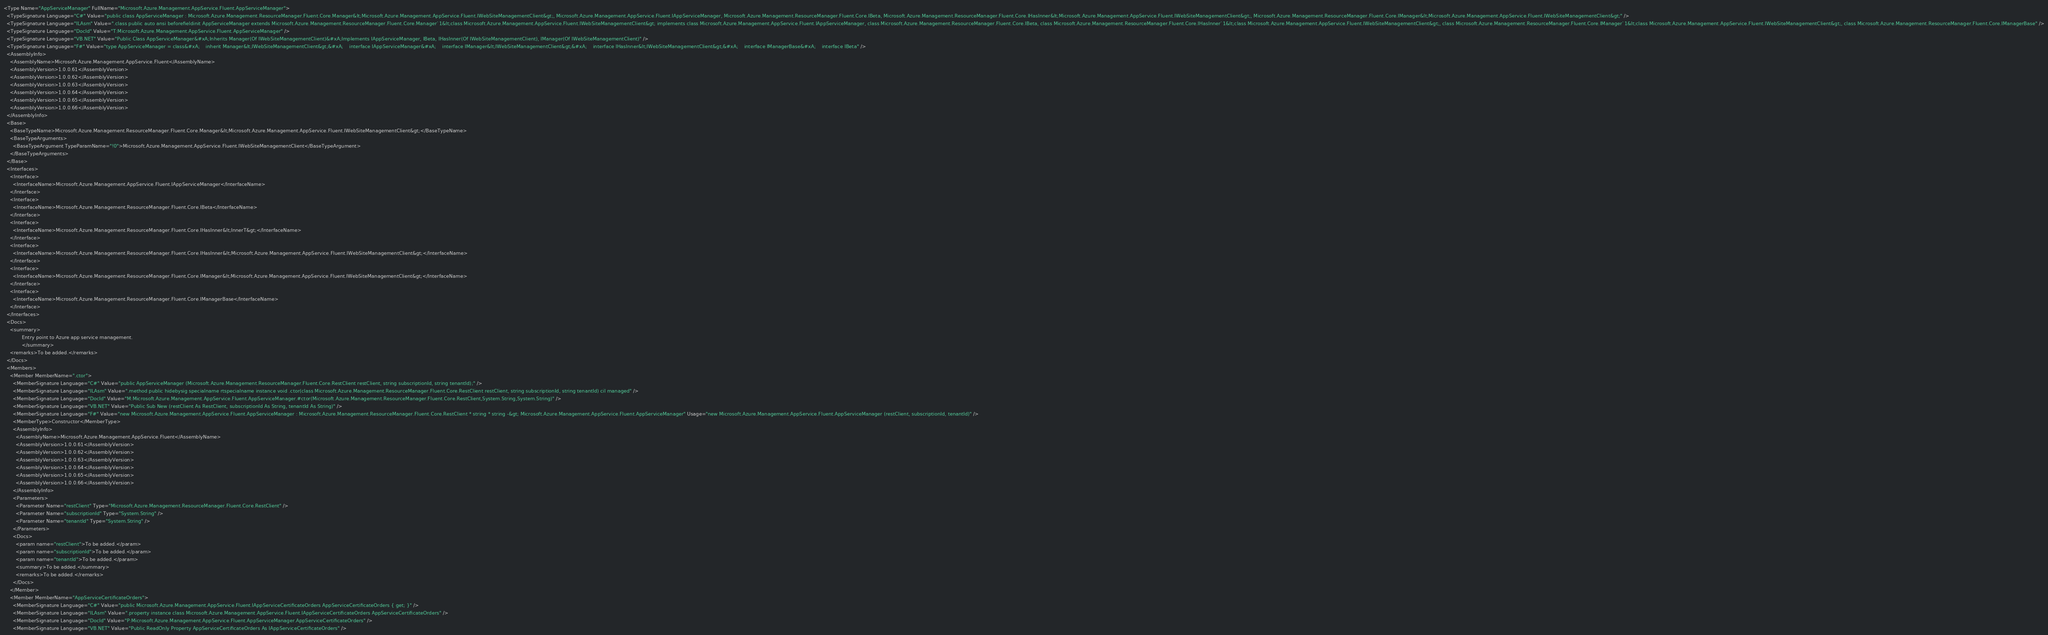Convert code to text. <code><loc_0><loc_0><loc_500><loc_500><_XML_><Type Name="AppServiceManager" FullName="Microsoft.Azure.Management.AppService.Fluent.AppServiceManager">
  <TypeSignature Language="C#" Value="public class AppServiceManager : Microsoft.Azure.Management.ResourceManager.Fluent.Core.Manager&lt;Microsoft.Azure.Management.AppService.Fluent.IWebSiteManagementClient&gt;, Microsoft.Azure.Management.AppService.Fluent.IAppServiceManager, Microsoft.Azure.Management.ResourceManager.Fluent.Core.IBeta, Microsoft.Azure.Management.ResourceManager.Fluent.Core.IHasInner&lt;Microsoft.Azure.Management.AppService.Fluent.IWebSiteManagementClient&gt;, Microsoft.Azure.Management.ResourceManager.Fluent.Core.IManager&lt;Microsoft.Azure.Management.AppService.Fluent.IWebSiteManagementClient&gt;" />
  <TypeSignature Language="ILAsm" Value=".class public auto ansi beforefieldinit AppServiceManager extends Microsoft.Azure.Management.ResourceManager.Fluent.Core.Manager`1&lt;class Microsoft.Azure.Management.AppService.Fluent.IWebSiteManagementClient&gt; implements class Microsoft.Azure.Management.AppService.Fluent.IAppServiceManager, class Microsoft.Azure.Management.ResourceManager.Fluent.Core.IBeta, class Microsoft.Azure.Management.ResourceManager.Fluent.Core.IHasInner`1&lt;class Microsoft.Azure.Management.AppService.Fluent.IWebSiteManagementClient&gt;, class Microsoft.Azure.Management.ResourceManager.Fluent.Core.IManager`1&lt;class Microsoft.Azure.Management.AppService.Fluent.IWebSiteManagementClient&gt;, class Microsoft.Azure.Management.ResourceManager.Fluent.Core.IManagerBase" />
  <TypeSignature Language="DocId" Value="T:Microsoft.Azure.Management.AppService.Fluent.AppServiceManager" />
  <TypeSignature Language="VB.NET" Value="Public Class AppServiceManager&#xA;Inherits Manager(Of IWebSiteManagementClient)&#xA;Implements IAppServiceManager, IBeta, IHasInner(Of IWebSiteManagementClient), IManager(Of IWebSiteManagementClient)" />
  <TypeSignature Language="F#" Value="type AppServiceManager = class&#xA;    inherit Manager&lt;IWebSiteManagementClient&gt;&#xA;    interface IAppServiceManager&#xA;    interface IManager&lt;IWebSiteManagementClient&gt;&#xA;    interface IHasInner&lt;IWebSiteManagementClient&gt;&#xA;    interface IManagerBase&#xA;    interface IBeta" />
  <AssemblyInfo>
    <AssemblyName>Microsoft.Azure.Management.AppService.Fluent</AssemblyName>
    <AssemblyVersion>1.0.0.61</AssemblyVersion>
    <AssemblyVersion>1.0.0.62</AssemblyVersion>
    <AssemblyVersion>1.0.0.63</AssemblyVersion>
    <AssemblyVersion>1.0.0.64</AssemblyVersion>
    <AssemblyVersion>1.0.0.65</AssemblyVersion>
    <AssemblyVersion>1.0.0.66</AssemblyVersion>
  </AssemblyInfo>
  <Base>
    <BaseTypeName>Microsoft.Azure.Management.ResourceManager.Fluent.Core.Manager&lt;Microsoft.Azure.Management.AppService.Fluent.IWebSiteManagementClient&gt;</BaseTypeName>
    <BaseTypeArguments>
      <BaseTypeArgument TypeParamName="!0">Microsoft.Azure.Management.AppService.Fluent.IWebSiteManagementClient</BaseTypeArgument>
    </BaseTypeArguments>
  </Base>
  <Interfaces>
    <Interface>
      <InterfaceName>Microsoft.Azure.Management.AppService.Fluent.IAppServiceManager</InterfaceName>
    </Interface>
    <Interface>
      <InterfaceName>Microsoft.Azure.Management.ResourceManager.Fluent.Core.IBeta</InterfaceName>
    </Interface>
    <Interface>
      <InterfaceName>Microsoft.Azure.Management.ResourceManager.Fluent.Core.IHasInner&lt;InnerT&gt;</InterfaceName>
    </Interface>
    <Interface>
      <InterfaceName>Microsoft.Azure.Management.ResourceManager.Fluent.Core.IHasInner&lt;Microsoft.Azure.Management.AppService.Fluent.IWebSiteManagementClient&gt;</InterfaceName>
    </Interface>
    <Interface>
      <InterfaceName>Microsoft.Azure.Management.ResourceManager.Fluent.Core.IManager&lt;Microsoft.Azure.Management.AppService.Fluent.IWebSiteManagementClient&gt;</InterfaceName>
    </Interface>
    <Interface>
      <InterfaceName>Microsoft.Azure.Management.ResourceManager.Fluent.Core.IManagerBase</InterfaceName>
    </Interface>
  </Interfaces>
  <Docs>
    <summary>
            Entry point to Azure app service management.
            </summary>
    <remarks>To be added.</remarks>
  </Docs>
  <Members>
    <Member MemberName=".ctor">
      <MemberSignature Language="C#" Value="public AppServiceManager (Microsoft.Azure.Management.ResourceManager.Fluent.Core.RestClient restClient, string subscriptionId, string tenantId);" />
      <MemberSignature Language="ILAsm" Value=".method public hidebysig specialname rtspecialname instance void .ctor(class Microsoft.Azure.Management.ResourceManager.Fluent.Core.RestClient restClient, string subscriptionId, string tenantId) cil managed" />
      <MemberSignature Language="DocId" Value="M:Microsoft.Azure.Management.AppService.Fluent.AppServiceManager.#ctor(Microsoft.Azure.Management.ResourceManager.Fluent.Core.RestClient,System.String,System.String)" />
      <MemberSignature Language="VB.NET" Value="Public Sub New (restClient As RestClient, subscriptionId As String, tenantId As String)" />
      <MemberSignature Language="F#" Value="new Microsoft.Azure.Management.AppService.Fluent.AppServiceManager : Microsoft.Azure.Management.ResourceManager.Fluent.Core.RestClient * string * string -&gt; Microsoft.Azure.Management.AppService.Fluent.AppServiceManager" Usage="new Microsoft.Azure.Management.AppService.Fluent.AppServiceManager (restClient, subscriptionId, tenantId)" />
      <MemberType>Constructor</MemberType>
      <AssemblyInfo>
        <AssemblyName>Microsoft.Azure.Management.AppService.Fluent</AssemblyName>
        <AssemblyVersion>1.0.0.61</AssemblyVersion>
        <AssemblyVersion>1.0.0.62</AssemblyVersion>
        <AssemblyVersion>1.0.0.63</AssemblyVersion>
        <AssemblyVersion>1.0.0.64</AssemblyVersion>
        <AssemblyVersion>1.0.0.65</AssemblyVersion>
        <AssemblyVersion>1.0.0.66</AssemblyVersion>
      </AssemblyInfo>
      <Parameters>
        <Parameter Name="restClient" Type="Microsoft.Azure.Management.ResourceManager.Fluent.Core.RestClient" />
        <Parameter Name="subscriptionId" Type="System.String" />
        <Parameter Name="tenantId" Type="System.String" />
      </Parameters>
      <Docs>
        <param name="restClient">To be added.</param>
        <param name="subscriptionId">To be added.</param>
        <param name="tenantId">To be added.</param>
        <summary>To be added.</summary>
        <remarks>To be added.</remarks>
      </Docs>
    </Member>
    <Member MemberName="AppServiceCertificateOrders">
      <MemberSignature Language="C#" Value="public Microsoft.Azure.Management.AppService.Fluent.IAppServiceCertificateOrders AppServiceCertificateOrders { get; }" />
      <MemberSignature Language="ILAsm" Value=".property instance class Microsoft.Azure.Management.AppService.Fluent.IAppServiceCertificateOrders AppServiceCertificateOrders" />
      <MemberSignature Language="DocId" Value="P:Microsoft.Azure.Management.AppService.Fluent.AppServiceManager.AppServiceCertificateOrders" />
      <MemberSignature Language="VB.NET" Value="Public ReadOnly Property AppServiceCertificateOrders As IAppServiceCertificateOrders" /></code> 